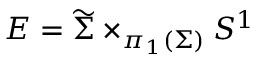Convert formula to latex. <formula><loc_0><loc_0><loc_500><loc_500>E = \widetilde { \Sigma } \times _ { \pi _ { 1 } ( \Sigma ) } S ^ { 1 }</formula> 